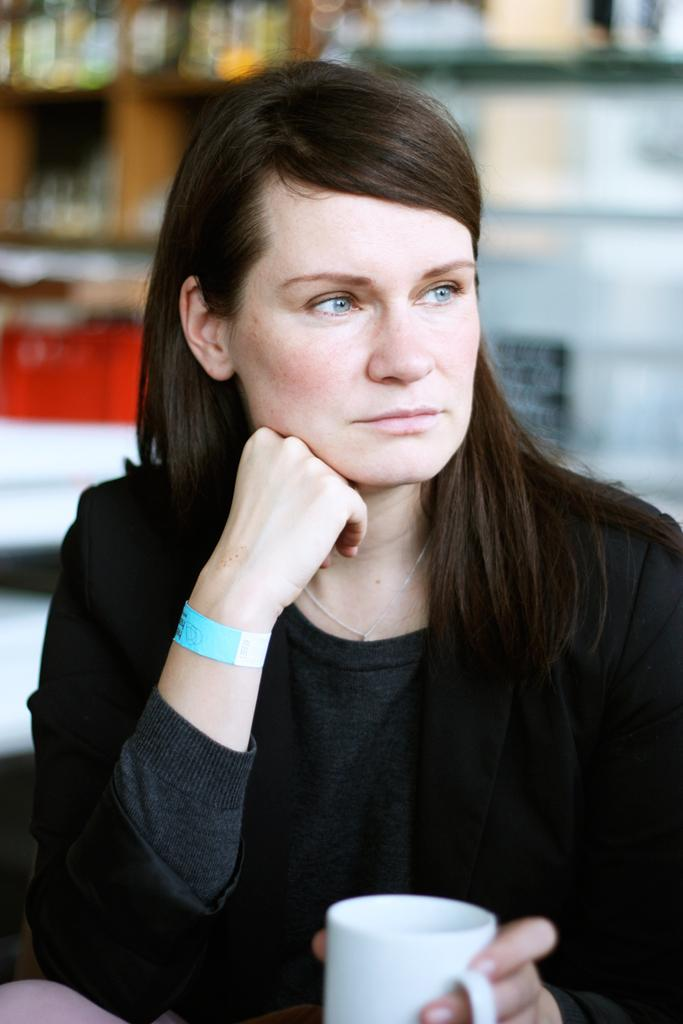Who is present in the image? There is a woman in the image. What is the woman holding in her hand? The woman is holding a cup in her hand. What color is the dock in the image? There is no dock present in the image. What does the cup smell like in the image? The smell of the cup cannot be determined from the image alone. 